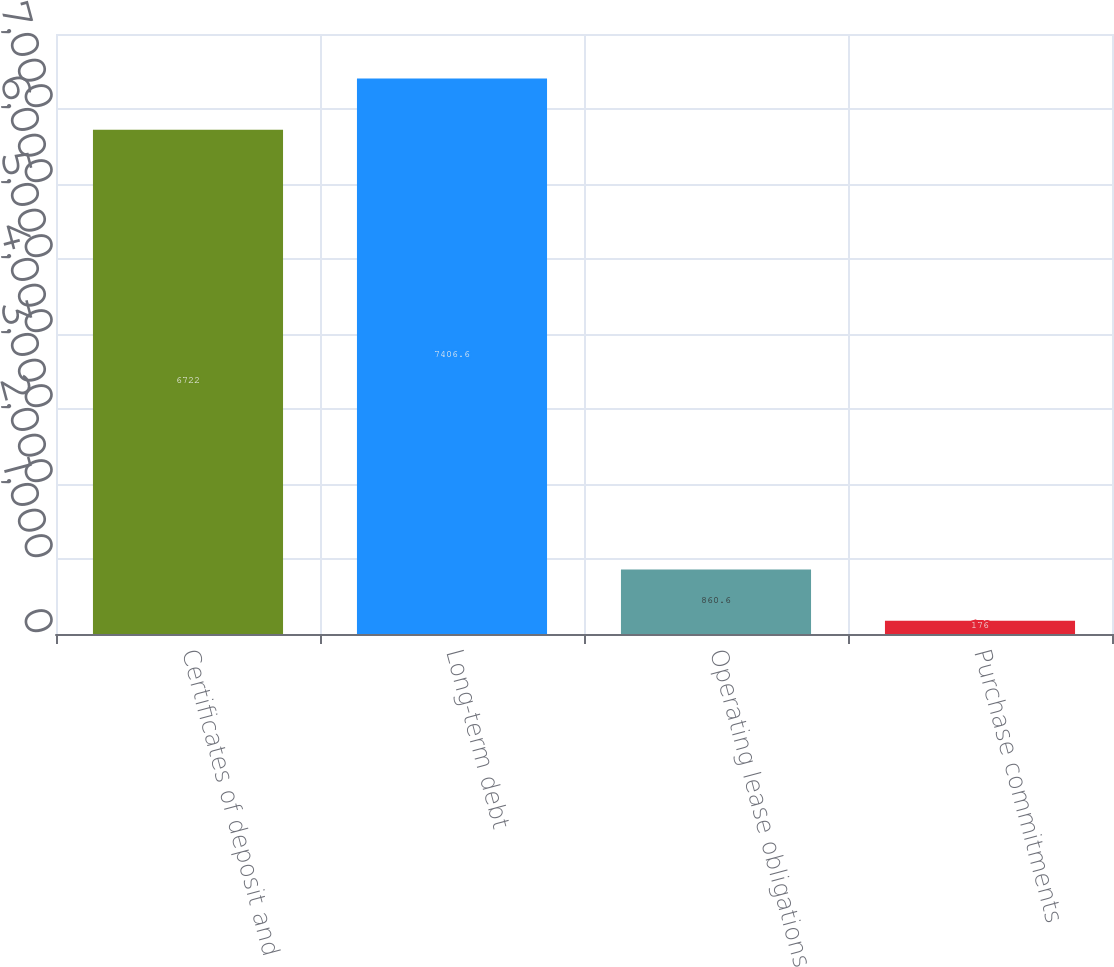Convert chart to OTSL. <chart><loc_0><loc_0><loc_500><loc_500><bar_chart><fcel>Certificates of deposit and<fcel>Long-term debt<fcel>Operating lease obligations<fcel>Purchase commitments<nl><fcel>6722<fcel>7406.6<fcel>860.6<fcel>176<nl></chart> 